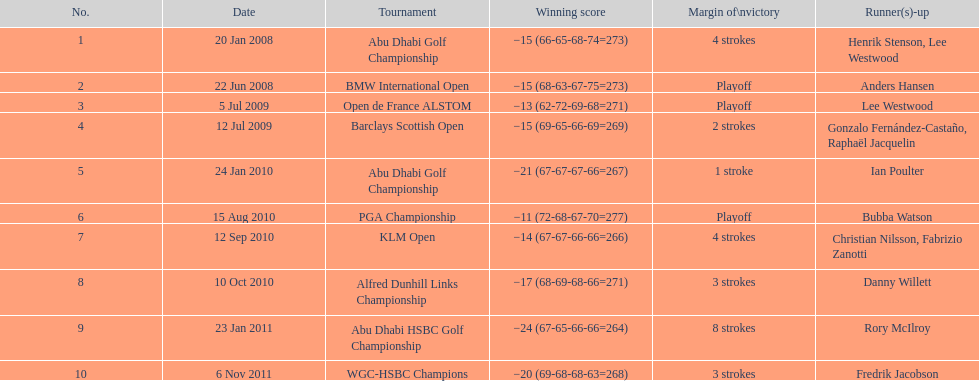How many winning scores were less than -14? 2. 